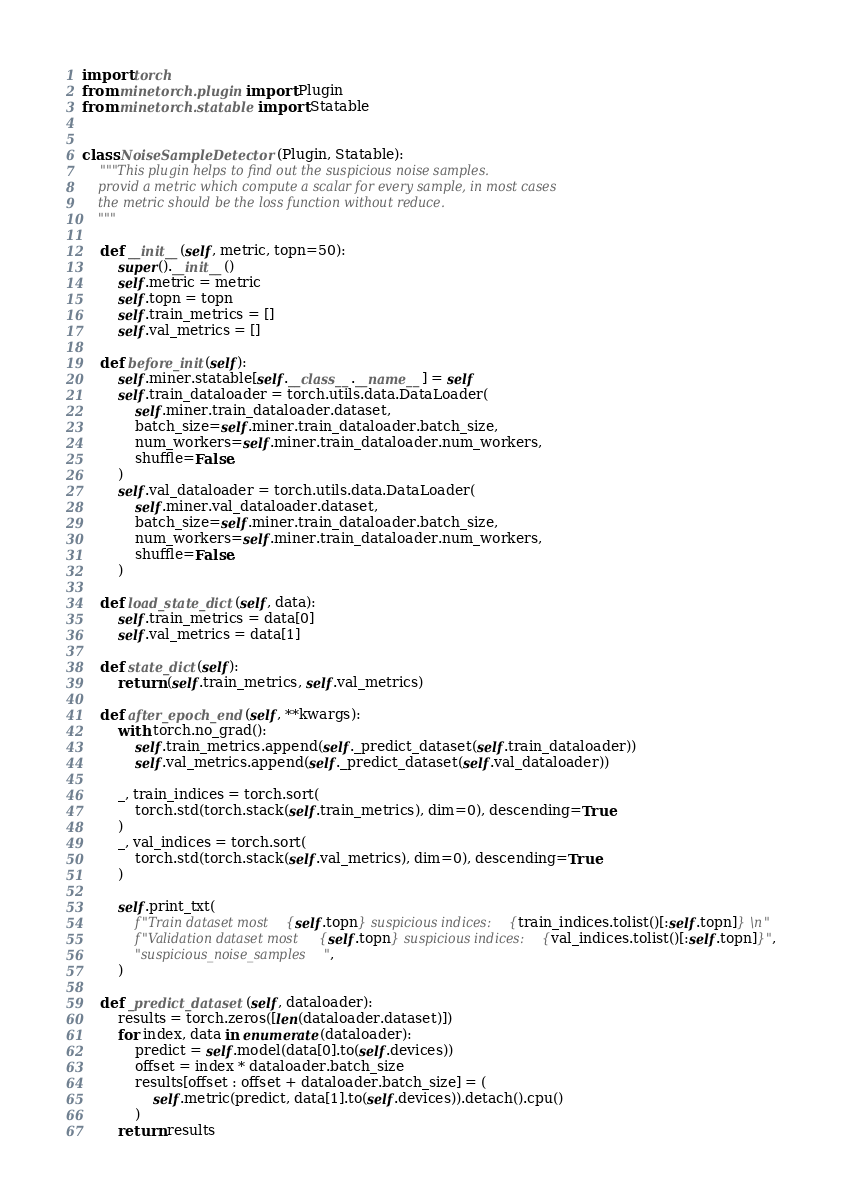<code> <loc_0><loc_0><loc_500><loc_500><_Python_>import torch
from minetorch.plugin import Plugin
from minetorch.statable import Statable


class NoiseSampleDetector(Plugin, Statable):
    """This plugin helps to find out the suspicious noise samples.
    provid a metric which compute a scalar for every sample, in most cases
    the metric should be the loss function without reduce.
    """

    def __init__(self, metric, topn=50):
        super().__init__()
        self.metric = metric
        self.topn = topn
        self.train_metrics = []
        self.val_metrics = []

    def before_init(self):
        self.miner.statable[self.__class__.__name__] = self
        self.train_dataloader = torch.utils.data.DataLoader(
            self.miner.train_dataloader.dataset,
            batch_size=self.miner.train_dataloader.batch_size,
            num_workers=self.miner.train_dataloader.num_workers,
            shuffle=False,
        )
        self.val_dataloader = torch.utils.data.DataLoader(
            self.miner.val_dataloader.dataset,
            batch_size=self.miner.train_dataloader.batch_size,
            num_workers=self.miner.train_dataloader.num_workers,
            shuffle=False,
        )

    def load_state_dict(self, data):
        self.train_metrics = data[0]
        self.val_metrics = data[1]

    def state_dict(self):
        return (self.train_metrics, self.val_metrics)

    def after_epoch_end(self, **kwargs):
        with torch.no_grad():
            self.train_metrics.append(self._predict_dataset(self.train_dataloader))
            self.val_metrics.append(self._predict_dataset(self.val_dataloader))

        _, train_indices = torch.sort(
            torch.std(torch.stack(self.train_metrics), dim=0), descending=True
        )
        _, val_indices = torch.sort(
            torch.std(torch.stack(self.val_metrics), dim=0), descending=True
        )

        self.print_txt(
            f"Train dataset most {self.topn} suspicious indices: {train_indices.tolist()[:self.topn]} \n"
            f"Validation dataset most {self.topn} suspicious indices: {val_indices.tolist()[:self.topn]}",
            "suspicious_noise_samples",
        )

    def _predict_dataset(self, dataloader):
        results = torch.zeros([len(dataloader.dataset)])
        for index, data in enumerate(dataloader):
            predict = self.model(data[0].to(self.devices))
            offset = index * dataloader.batch_size
            results[offset : offset + dataloader.batch_size] = (
                self.metric(predict, data[1].to(self.devices)).detach().cpu()
            )
        return results
</code> 